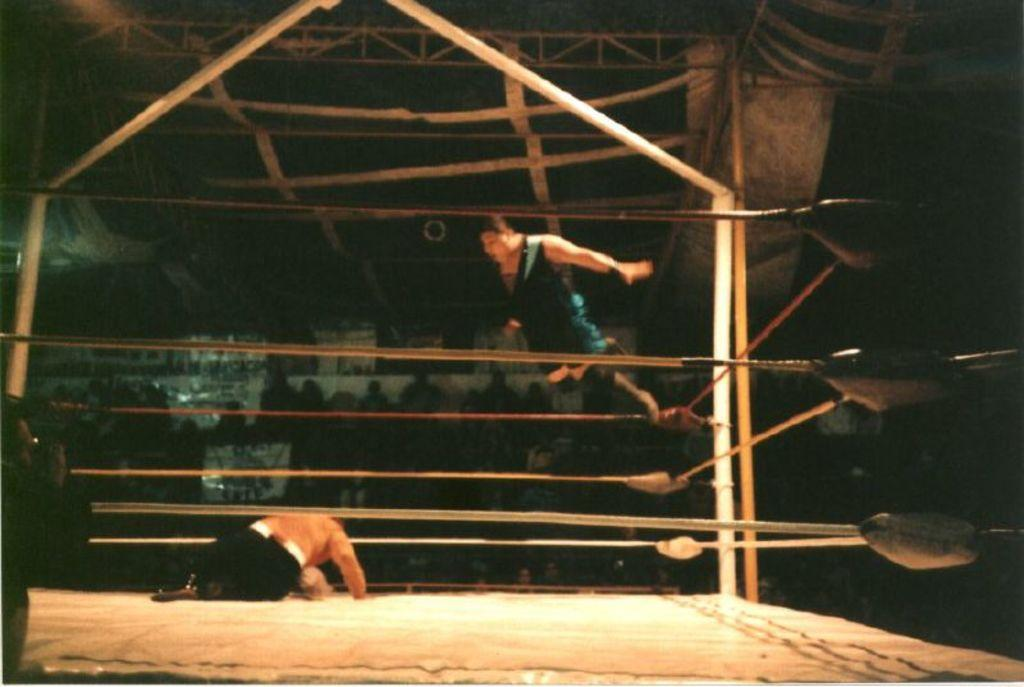What is happening in the image involving the two persons? There are two persons in the wrestling ring, suggesting they are engaged in a wrestling match. What can be seen in the background of the image? There are audience members sitting in the backdrop. What is the source of light in the image? Lights are attached to the ceiling. What type of grain is being harvested by the representative in the town depicted in the image? There is no representative or town present in the image, and no grain is being harvested. 